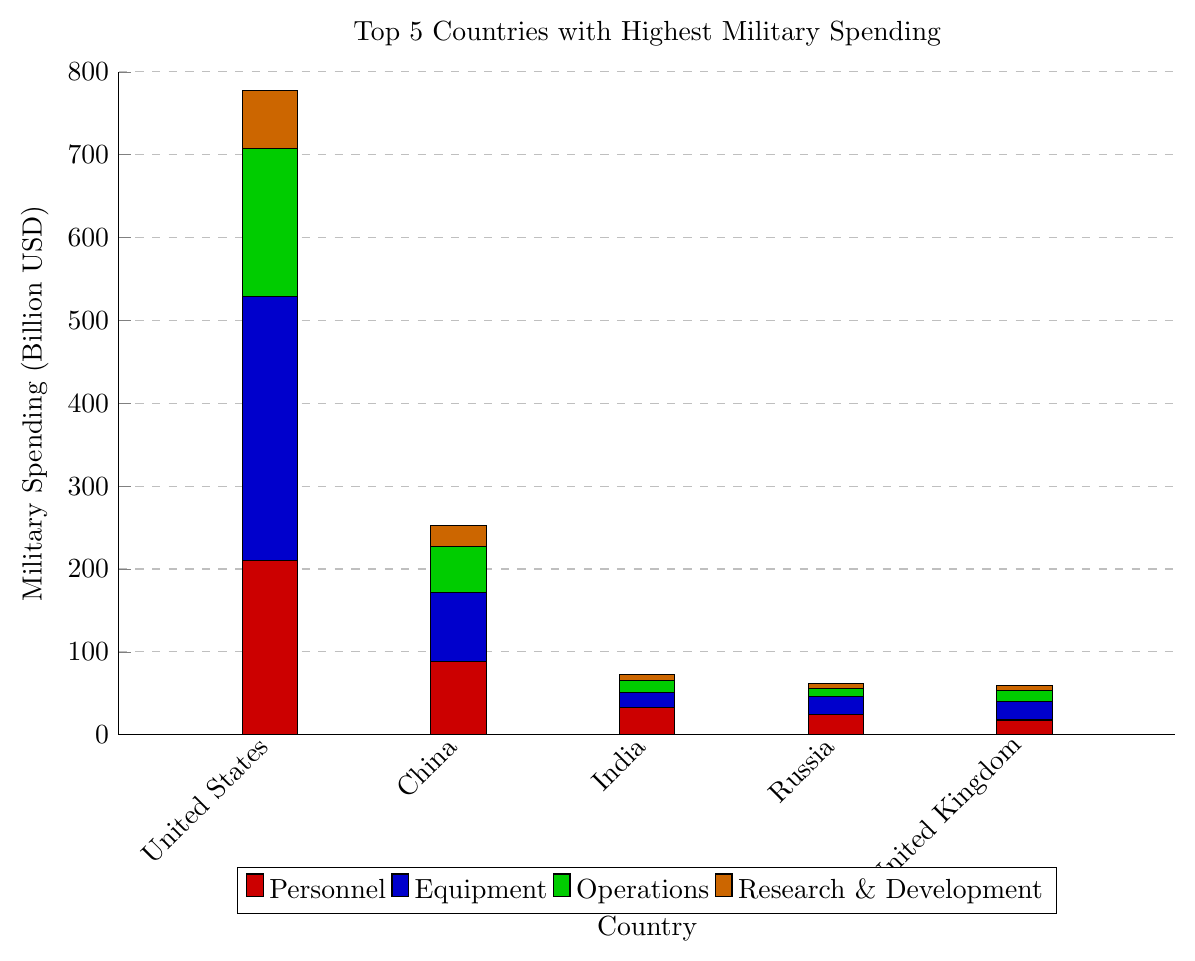Which country spends the most on military equipment? To find the country that spends the most on military equipment, observe the blue bars for each country and identify the tallest one. The United States has the tallest blue bar, indicating the highest spending on equipment.
Answer: United States Which country has the lowest total military spending? To determine the country with the lowest total military spending, compare the overall heights of the bars. The United Kingdom has the smallest combined height for all segments.
Answer: United Kingdom What is the combined spending on personnel for China and India? Sum the heights of the red bars for China and India: China's personnel spending is 88.2 billion USD, and India's personnel spending is 32.805 billion USD. The combined spending is 88.2 + 32.805 = 121.005 billion USD.
Answer: 121.005 billion USD How much more does the United States spend on operations than Russia? Compare the green bars for the United States and Russia: the United States spends 178.94 billion USD on operations, and Russia spends 9.255 billion USD. The difference is 178.94 - 9.255 = 169.685 billion USD.
Answer: 169.685 billion USD What is the percentage of total military spending allocated to research and development in India? Calculate the total military spending for India by adding up all the segments: 32.805 + 18.225 + 14.58 + 7.29 = 72.9 billion USD. The spending on research and development is 7.29 billion USD. The percentage is (7.29 / 72.9) * 100% = 10%.
Answer: 10% Which two countries have equal percentages of their budget allocated to research and development? Observe the percentages for research and development for all countries: the United States, China, India, and Russia each allocate 10% of their budget to research and development. Hence, the two countries with equal percentages are any two among these four.
Answer: United States and China (or any other two from United States, China, India, and Russia) How does the spending on equipment by the United Kingdom compare to that of China? Compare the blue bars for the United Kingdom and China: the United Kingdom spends 22.496 billion USD on equipment, whereas China spends 83.16 billion USD. The United Kingdom spends less on equipment than China.
Answer: Less What is the total military spending for the top three countries combined? Add the total spending for United States, China, and India: United States (778 billion USD) + China (252 billion USD) + India (72.9 billion USD) = 1102.9 billion USD.
Answer: 1102.9 billion USD 